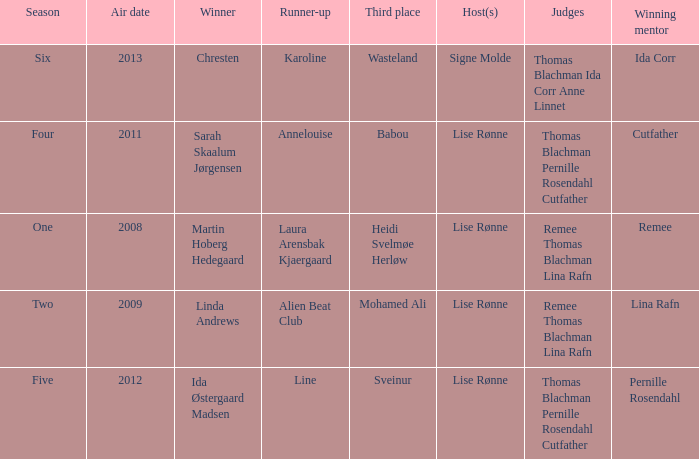Who won third place in season four? Babou. 